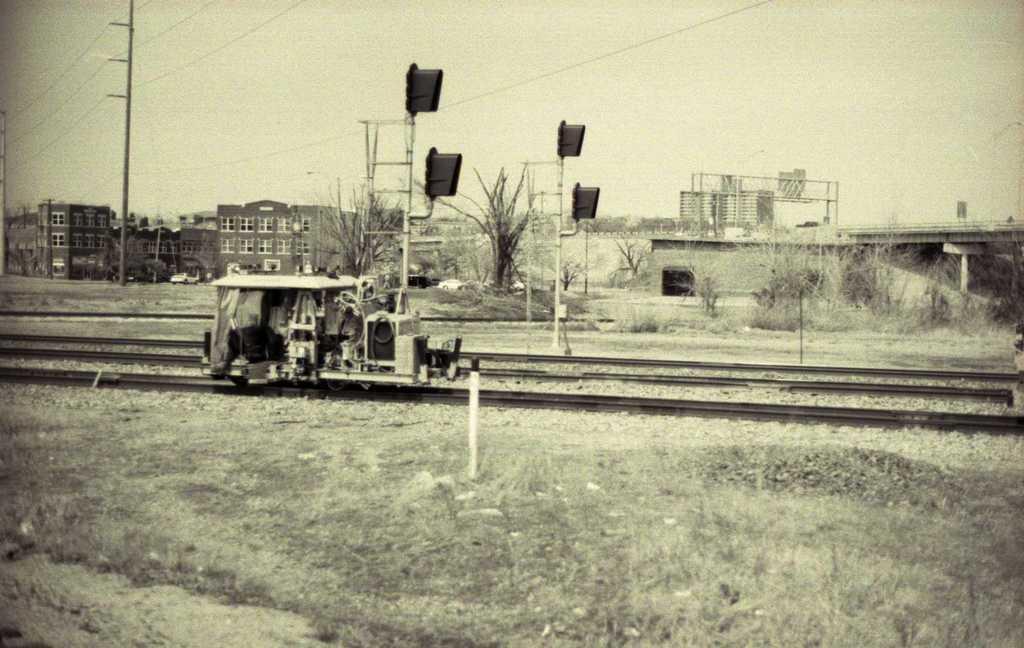Describe this image in one or two sentences. This is a black and white image I can see a railway track and signals on the track with a construction and some buildings behind the track and some electric poles and at the bottom of the image I can see the ground. 